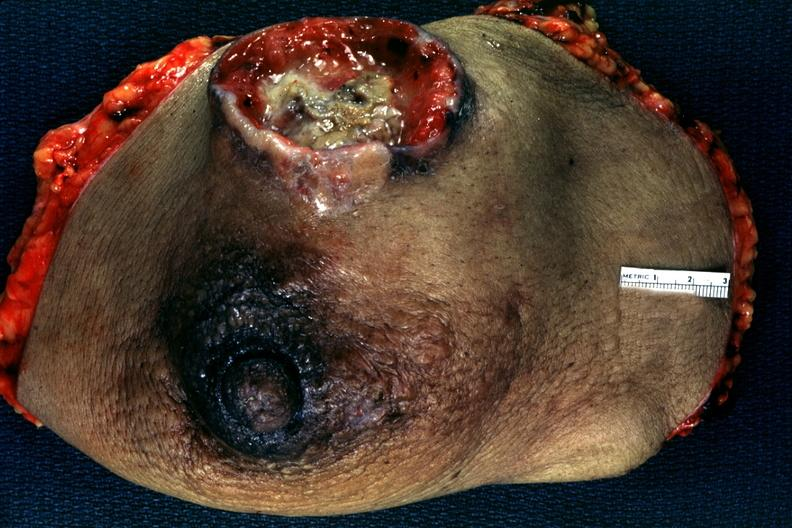does this image show large ulcerating carcinoma surgical specimen?
Answer the question using a single word or phrase. Yes 